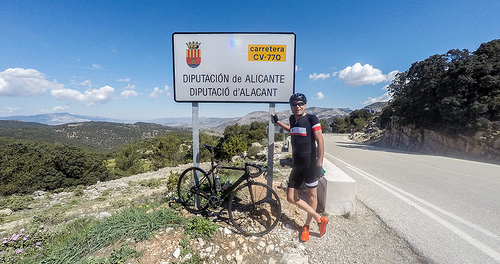<image>
Is there a cycle on the board? No. The cycle is not positioned on the board. They may be near each other, but the cycle is not supported by or resting on top of the board. Is the mountain behind the cycle? Yes. From this viewpoint, the mountain is positioned behind the cycle, with the cycle partially or fully occluding the mountain. Where is the bike in relation to the sign? Is it under the sign? Yes. The bike is positioned underneath the sign, with the sign above it in the vertical space. 